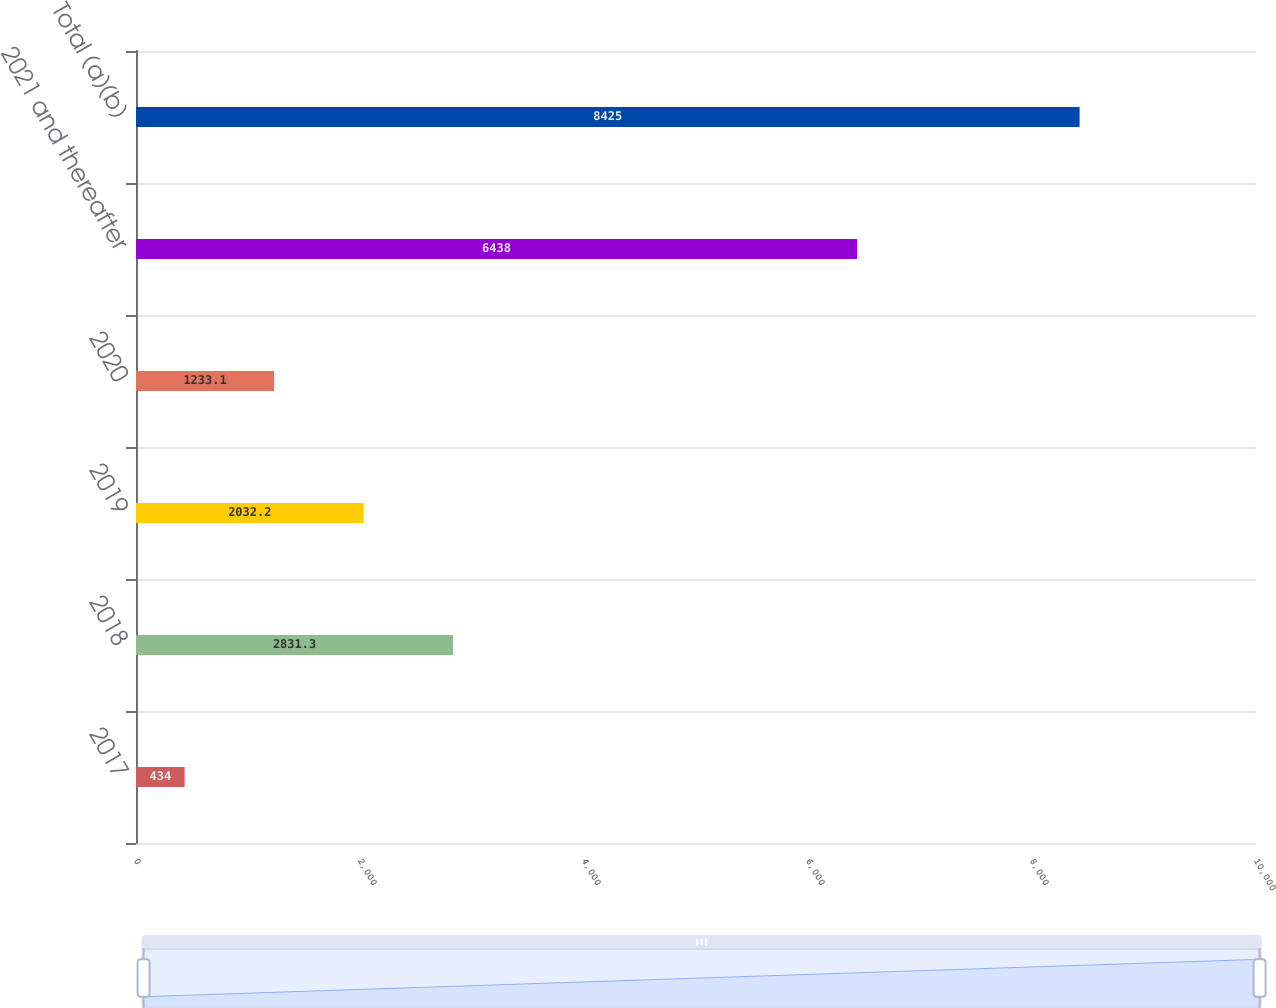<chart> <loc_0><loc_0><loc_500><loc_500><bar_chart><fcel>2017<fcel>2018<fcel>2019<fcel>2020<fcel>2021 and thereafter<fcel>Total (a)(b)<nl><fcel>434<fcel>2831.3<fcel>2032.2<fcel>1233.1<fcel>6438<fcel>8425<nl></chart> 